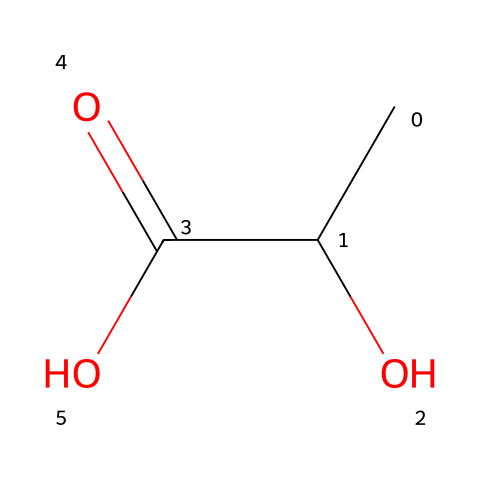What is the common name of this molecule? The SMILES representation describes a carboxylic acid with a hydroxyl group on the adjacent carbon, which is known as lactic acid.
Answer: lactic acid How many carbon atoms are present in this molecule? Analyzing the SMILES string, we see “CC”, meaning there are two carbon atoms in a chain, plus another carbon connected to the functional groups, totaling three carbon atoms.
Answer: three What types of functional groups can be identified in this structure? The molecule contains a hydroxyl group (-OH) and a carboxylic acid group (-COOH), which are both clearly denoted in the SMILES.
Answer: hydroxyl and carboxylic acid What is the total number of hydrogen atoms in this molecule? By breaking down the SMILES, we observe that for three carbons and considering the hydrogen connected to each functional group, there are a total of six hydrogen atoms.
Answer: six What type of isomerism does this molecule exhibit? This molecule can exhibit structural isomerism due to the arrangement of its atoms, particularly since it has multiple functional groups.
Answer: structural isomerism Which part of this molecule is responsible for its biodegradable property? The carboxylic acid functional group is responsible for the biodegradable property due to its ability to undergo esterification and hydrolysis in the environment.
Answer: carboxylic acid 